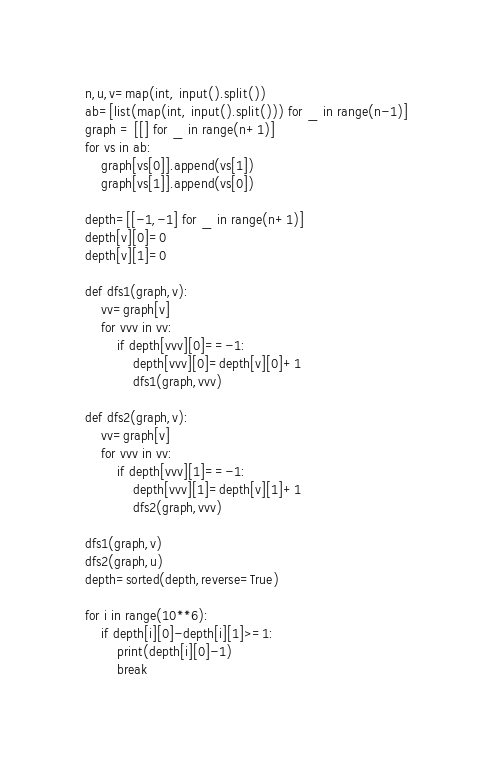Convert code to text. <code><loc_0><loc_0><loc_500><loc_500><_Python_>n,u,v=map(int, input().split())
ab=[list(map(int, input().split())) for _ in range(n-1)]
graph = [[] for _ in range(n+1)]
for vs in ab:
    graph[vs[0]].append(vs[1])
    graph[vs[1]].append(vs[0])

depth=[[-1,-1] for _ in range(n+1)]
depth[v][0]=0
depth[v][1]=0

def dfs1(graph,v):
    vv=graph[v]
    for vvv in vv:
        if depth[vvv][0]==-1:
            depth[vvv][0]=depth[v][0]+1
            dfs1(graph,vvv)

def dfs2(graph,v):
    vv=graph[v]
    for vvv in vv:
        if depth[vvv][1]==-1:
            depth[vvv][1]=depth[v][1]+1
            dfs2(graph,vvv)

dfs1(graph,v)
dfs2(graph,u)
depth=sorted(depth,reverse=True)

for i in range(10**6):
    if depth[i][0]-depth[i][1]>=1:
        print(depth[i][0]-1)
        break
</code> 